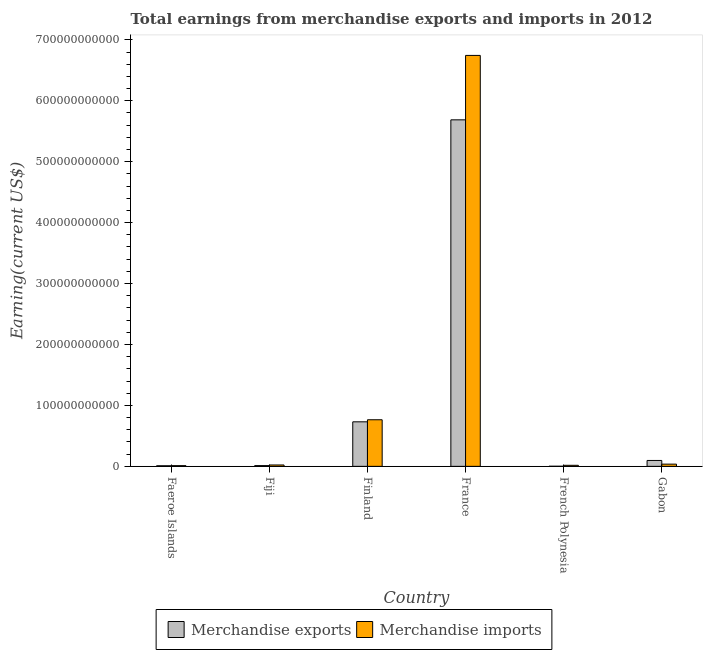How many groups of bars are there?
Give a very brief answer. 6. Are the number of bars per tick equal to the number of legend labels?
Your answer should be compact. Yes. Are the number of bars on each tick of the X-axis equal?
Your answer should be compact. Yes. How many bars are there on the 2nd tick from the left?
Give a very brief answer. 2. What is the label of the 4th group of bars from the left?
Offer a terse response. France. In how many cases, is the number of bars for a given country not equal to the number of legend labels?
Your response must be concise. 0. What is the earnings from merchandise exports in French Polynesia?
Give a very brief answer. 1.39e+08. Across all countries, what is the maximum earnings from merchandise imports?
Your answer should be very brief. 6.74e+11. Across all countries, what is the minimum earnings from merchandise imports?
Ensure brevity in your answer.  1.15e+09. In which country was the earnings from merchandise exports maximum?
Provide a short and direct response. France. In which country was the earnings from merchandise imports minimum?
Give a very brief answer. Faeroe Islands. What is the total earnings from merchandise exports in the graph?
Your response must be concise. 6.54e+11. What is the difference between the earnings from merchandise imports in Faeroe Islands and that in Finland?
Ensure brevity in your answer.  -7.53e+1. What is the difference between the earnings from merchandise exports in Fiji and the earnings from merchandise imports in Faeroe Islands?
Your response must be concise. 6.75e+07. What is the average earnings from merchandise exports per country?
Provide a succinct answer. 1.09e+11. What is the difference between the earnings from merchandise imports and earnings from merchandise exports in French Polynesia?
Offer a terse response. 1.57e+09. In how many countries, is the earnings from merchandise imports greater than 180000000000 US$?
Keep it short and to the point. 1. What is the ratio of the earnings from merchandise imports in Faeroe Islands to that in French Polynesia?
Make the answer very short. 0.68. Is the difference between the earnings from merchandise exports in Faeroe Islands and French Polynesia greater than the difference between the earnings from merchandise imports in Faeroe Islands and French Polynesia?
Keep it short and to the point. Yes. What is the difference between the highest and the second highest earnings from merchandise imports?
Make the answer very short. 5.98e+11. What is the difference between the highest and the lowest earnings from merchandise exports?
Provide a succinct answer. 5.69e+11. How many bars are there?
Provide a short and direct response. 12. Are all the bars in the graph horizontal?
Give a very brief answer. No. What is the difference between two consecutive major ticks on the Y-axis?
Provide a succinct answer. 1.00e+11. Does the graph contain grids?
Provide a succinct answer. No. Where does the legend appear in the graph?
Offer a terse response. Bottom center. How are the legend labels stacked?
Offer a very short reply. Horizontal. What is the title of the graph?
Provide a short and direct response. Total earnings from merchandise exports and imports in 2012. What is the label or title of the X-axis?
Offer a terse response. Country. What is the label or title of the Y-axis?
Your answer should be very brief. Earning(current US$). What is the Earning(current US$) in Merchandise exports in Faeroe Islands?
Your answer should be very brief. 9.52e+08. What is the Earning(current US$) in Merchandise imports in Faeroe Islands?
Give a very brief answer. 1.15e+09. What is the Earning(current US$) of Merchandise exports in Fiji?
Offer a very short reply. 1.22e+09. What is the Earning(current US$) in Merchandise imports in Fiji?
Your response must be concise. 2.25e+09. What is the Earning(current US$) of Merchandise exports in Finland?
Offer a very short reply. 7.31e+1. What is the Earning(current US$) of Merchandise imports in Finland?
Give a very brief answer. 7.65e+1. What is the Earning(current US$) in Merchandise exports in France?
Offer a terse response. 5.69e+11. What is the Earning(current US$) of Merchandise imports in France?
Keep it short and to the point. 6.74e+11. What is the Earning(current US$) of Merchandise exports in French Polynesia?
Ensure brevity in your answer.  1.39e+08. What is the Earning(current US$) of Merchandise imports in French Polynesia?
Your response must be concise. 1.71e+09. What is the Earning(current US$) in Merchandise exports in Gabon?
Your answer should be compact. 9.66e+09. What is the Earning(current US$) of Merchandise imports in Gabon?
Make the answer very short. 3.63e+09. Across all countries, what is the maximum Earning(current US$) in Merchandise exports?
Ensure brevity in your answer.  5.69e+11. Across all countries, what is the maximum Earning(current US$) in Merchandise imports?
Offer a terse response. 6.74e+11. Across all countries, what is the minimum Earning(current US$) of Merchandise exports?
Ensure brevity in your answer.  1.39e+08. Across all countries, what is the minimum Earning(current US$) in Merchandise imports?
Keep it short and to the point. 1.15e+09. What is the total Earning(current US$) of Merchandise exports in the graph?
Offer a very short reply. 6.54e+11. What is the total Earning(current US$) in Merchandise imports in the graph?
Provide a succinct answer. 7.60e+11. What is the difference between the Earning(current US$) in Merchandise exports in Faeroe Islands and that in Fiji?
Ensure brevity in your answer.  -2.69e+08. What is the difference between the Earning(current US$) in Merchandise imports in Faeroe Islands and that in Fiji?
Your answer should be very brief. -1.10e+09. What is the difference between the Earning(current US$) of Merchandise exports in Faeroe Islands and that in Finland?
Keep it short and to the point. -7.21e+1. What is the difference between the Earning(current US$) in Merchandise imports in Faeroe Islands and that in Finland?
Offer a very short reply. -7.53e+1. What is the difference between the Earning(current US$) in Merchandise exports in Faeroe Islands and that in France?
Provide a short and direct response. -5.68e+11. What is the difference between the Earning(current US$) in Merchandise imports in Faeroe Islands and that in France?
Make the answer very short. -6.73e+11. What is the difference between the Earning(current US$) in Merchandise exports in Faeroe Islands and that in French Polynesia?
Keep it short and to the point. 8.13e+08. What is the difference between the Earning(current US$) in Merchandise imports in Faeroe Islands and that in French Polynesia?
Give a very brief answer. -5.52e+08. What is the difference between the Earning(current US$) of Merchandise exports in Faeroe Islands and that in Gabon?
Offer a very short reply. -8.71e+09. What is the difference between the Earning(current US$) of Merchandise imports in Faeroe Islands and that in Gabon?
Offer a very short reply. -2.48e+09. What is the difference between the Earning(current US$) in Merchandise exports in Fiji and that in Finland?
Your answer should be compact. -7.19e+1. What is the difference between the Earning(current US$) of Merchandise imports in Fiji and that in Finland?
Your answer should be very brief. -7.42e+1. What is the difference between the Earning(current US$) of Merchandise exports in Fiji and that in France?
Your answer should be very brief. -5.67e+11. What is the difference between the Earning(current US$) in Merchandise imports in Fiji and that in France?
Your answer should be compact. -6.72e+11. What is the difference between the Earning(current US$) in Merchandise exports in Fiji and that in French Polynesia?
Your response must be concise. 1.08e+09. What is the difference between the Earning(current US$) of Merchandise imports in Fiji and that in French Polynesia?
Your answer should be compact. 5.47e+08. What is the difference between the Earning(current US$) in Merchandise exports in Fiji and that in Gabon?
Offer a very short reply. -8.44e+09. What is the difference between the Earning(current US$) of Merchandise imports in Fiji and that in Gabon?
Your answer should be very brief. -1.38e+09. What is the difference between the Earning(current US$) in Merchandise exports in Finland and that in France?
Your answer should be very brief. -4.96e+11. What is the difference between the Earning(current US$) of Merchandise imports in Finland and that in France?
Offer a terse response. -5.98e+11. What is the difference between the Earning(current US$) of Merchandise exports in Finland and that in French Polynesia?
Provide a short and direct response. 7.29e+1. What is the difference between the Earning(current US$) in Merchandise imports in Finland and that in French Polynesia?
Make the answer very short. 7.48e+1. What is the difference between the Earning(current US$) in Merchandise exports in Finland and that in Gabon?
Keep it short and to the point. 6.34e+1. What is the difference between the Earning(current US$) of Merchandise imports in Finland and that in Gabon?
Your answer should be compact. 7.28e+1. What is the difference between the Earning(current US$) in Merchandise exports in France and that in French Polynesia?
Ensure brevity in your answer.  5.69e+11. What is the difference between the Earning(current US$) in Merchandise imports in France and that in French Polynesia?
Give a very brief answer. 6.73e+11. What is the difference between the Earning(current US$) in Merchandise exports in France and that in Gabon?
Keep it short and to the point. 5.59e+11. What is the difference between the Earning(current US$) in Merchandise imports in France and that in Gabon?
Your answer should be very brief. 6.71e+11. What is the difference between the Earning(current US$) of Merchandise exports in French Polynesia and that in Gabon?
Ensure brevity in your answer.  -9.52e+09. What is the difference between the Earning(current US$) of Merchandise imports in French Polynesia and that in Gabon?
Your answer should be very brief. -1.92e+09. What is the difference between the Earning(current US$) in Merchandise exports in Faeroe Islands and the Earning(current US$) in Merchandise imports in Fiji?
Offer a very short reply. -1.30e+09. What is the difference between the Earning(current US$) of Merchandise exports in Faeroe Islands and the Earning(current US$) of Merchandise imports in Finland?
Make the answer very short. -7.55e+1. What is the difference between the Earning(current US$) of Merchandise exports in Faeroe Islands and the Earning(current US$) of Merchandise imports in France?
Your answer should be compact. -6.73e+11. What is the difference between the Earning(current US$) of Merchandise exports in Faeroe Islands and the Earning(current US$) of Merchandise imports in French Polynesia?
Your answer should be very brief. -7.53e+08. What is the difference between the Earning(current US$) of Merchandise exports in Faeroe Islands and the Earning(current US$) of Merchandise imports in Gabon?
Ensure brevity in your answer.  -2.68e+09. What is the difference between the Earning(current US$) of Merchandise exports in Fiji and the Earning(current US$) of Merchandise imports in Finland?
Your answer should be compact. -7.52e+1. What is the difference between the Earning(current US$) of Merchandise exports in Fiji and the Earning(current US$) of Merchandise imports in France?
Ensure brevity in your answer.  -6.73e+11. What is the difference between the Earning(current US$) in Merchandise exports in Fiji and the Earning(current US$) in Merchandise imports in French Polynesia?
Provide a succinct answer. -4.85e+08. What is the difference between the Earning(current US$) of Merchandise exports in Fiji and the Earning(current US$) of Merchandise imports in Gabon?
Your answer should be compact. -2.41e+09. What is the difference between the Earning(current US$) of Merchandise exports in Finland and the Earning(current US$) of Merchandise imports in France?
Provide a short and direct response. -6.01e+11. What is the difference between the Earning(current US$) in Merchandise exports in Finland and the Earning(current US$) in Merchandise imports in French Polynesia?
Ensure brevity in your answer.  7.14e+1. What is the difference between the Earning(current US$) in Merchandise exports in Finland and the Earning(current US$) in Merchandise imports in Gabon?
Give a very brief answer. 6.94e+1. What is the difference between the Earning(current US$) of Merchandise exports in France and the Earning(current US$) of Merchandise imports in French Polynesia?
Keep it short and to the point. 5.67e+11. What is the difference between the Earning(current US$) in Merchandise exports in France and the Earning(current US$) in Merchandise imports in Gabon?
Ensure brevity in your answer.  5.65e+11. What is the difference between the Earning(current US$) in Merchandise exports in French Polynesia and the Earning(current US$) in Merchandise imports in Gabon?
Offer a very short reply. -3.49e+09. What is the average Earning(current US$) of Merchandise exports per country?
Keep it short and to the point. 1.09e+11. What is the average Earning(current US$) in Merchandise imports per country?
Your answer should be very brief. 1.27e+11. What is the difference between the Earning(current US$) in Merchandise exports and Earning(current US$) in Merchandise imports in Faeroe Islands?
Offer a very short reply. -2.01e+08. What is the difference between the Earning(current US$) in Merchandise exports and Earning(current US$) in Merchandise imports in Fiji?
Keep it short and to the point. -1.03e+09. What is the difference between the Earning(current US$) in Merchandise exports and Earning(current US$) in Merchandise imports in Finland?
Offer a terse response. -3.39e+09. What is the difference between the Earning(current US$) in Merchandise exports and Earning(current US$) in Merchandise imports in France?
Make the answer very short. -1.06e+11. What is the difference between the Earning(current US$) of Merchandise exports and Earning(current US$) of Merchandise imports in French Polynesia?
Your answer should be very brief. -1.57e+09. What is the difference between the Earning(current US$) of Merchandise exports and Earning(current US$) of Merchandise imports in Gabon?
Offer a very short reply. 6.03e+09. What is the ratio of the Earning(current US$) in Merchandise exports in Faeroe Islands to that in Fiji?
Offer a terse response. 0.78. What is the ratio of the Earning(current US$) of Merchandise imports in Faeroe Islands to that in Fiji?
Your response must be concise. 0.51. What is the ratio of the Earning(current US$) of Merchandise exports in Faeroe Islands to that in Finland?
Your response must be concise. 0.01. What is the ratio of the Earning(current US$) in Merchandise imports in Faeroe Islands to that in Finland?
Your response must be concise. 0.02. What is the ratio of the Earning(current US$) in Merchandise exports in Faeroe Islands to that in France?
Provide a short and direct response. 0. What is the ratio of the Earning(current US$) in Merchandise imports in Faeroe Islands to that in France?
Ensure brevity in your answer.  0. What is the ratio of the Earning(current US$) in Merchandise exports in Faeroe Islands to that in French Polynesia?
Your answer should be very brief. 6.85. What is the ratio of the Earning(current US$) in Merchandise imports in Faeroe Islands to that in French Polynesia?
Your answer should be compact. 0.68. What is the ratio of the Earning(current US$) of Merchandise exports in Faeroe Islands to that in Gabon?
Provide a short and direct response. 0.1. What is the ratio of the Earning(current US$) of Merchandise imports in Faeroe Islands to that in Gabon?
Offer a terse response. 0.32. What is the ratio of the Earning(current US$) of Merchandise exports in Fiji to that in Finland?
Your answer should be compact. 0.02. What is the ratio of the Earning(current US$) of Merchandise imports in Fiji to that in Finland?
Give a very brief answer. 0.03. What is the ratio of the Earning(current US$) of Merchandise exports in Fiji to that in France?
Make the answer very short. 0. What is the ratio of the Earning(current US$) of Merchandise imports in Fiji to that in France?
Provide a short and direct response. 0. What is the ratio of the Earning(current US$) in Merchandise exports in Fiji to that in French Polynesia?
Give a very brief answer. 8.79. What is the ratio of the Earning(current US$) in Merchandise imports in Fiji to that in French Polynesia?
Provide a succinct answer. 1.32. What is the ratio of the Earning(current US$) of Merchandise exports in Fiji to that in Gabon?
Offer a terse response. 0.13. What is the ratio of the Earning(current US$) in Merchandise imports in Fiji to that in Gabon?
Provide a succinct answer. 0.62. What is the ratio of the Earning(current US$) in Merchandise exports in Finland to that in France?
Offer a very short reply. 0.13. What is the ratio of the Earning(current US$) of Merchandise imports in Finland to that in France?
Your answer should be very brief. 0.11. What is the ratio of the Earning(current US$) in Merchandise exports in Finland to that in French Polynesia?
Keep it short and to the point. 526.12. What is the ratio of the Earning(current US$) in Merchandise imports in Finland to that in French Polynesia?
Your answer should be compact. 44.84. What is the ratio of the Earning(current US$) of Merchandise exports in Finland to that in Gabon?
Give a very brief answer. 7.56. What is the ratio of the Earning(current US$) in Merchandise imports in Finland to that in Gabon?
Your answer should be compact. 21.07. What is the ratio of the Earning(current US$) of Merchandise exports in France to that in French Polynesia?
Provide a succinct answer. 4094.4. What is the ratio of the Earning(current US$) in Merchandise imports in France to that in French Polynesia?
Keep it short and to the point. 395.45. What is the ratio of the Earning(current US$) of Merchandise exports in France to that in Gabon?
Give a very brief answer. 58.87. What is the ratio of the Earning(current US$) in Merchandise imports in France to that in Gabon?
Keep it short and to the point. 185.85. What is the ratio of the Earning(current US$) of Merchandise exports in French Polynesia to that in Gabon?
Make the answer very short. 0.01. What is the ratio of the Earning(current US$) of Merchandise imports in French Polynesia to that in Gabon?
Provide a short and direct response. 0.47. What is the difference between the highest and the second highest Earning(current US$) of Merchandise exports?
Your response must be concise. 4.96e+11. What is the difference between the highest and the second highest Earning(current US$) in Merchandise imports?
Ensure brevity in your answer.  5.98e+11. What is the difference between the highest and the lowest Earning(current US$) in Merchandise exports?
Offer a very short reply. 5.69e+11. What is the difference between the highest and the lowest Earning(current US$) of Merchandise imports?
Your answer should be compact. 6.73e+11. 